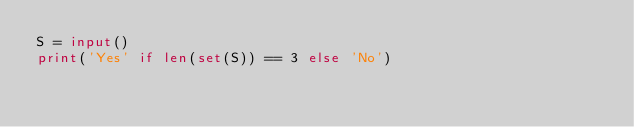Convert code to text. <code><loc_0><loc_0><loc_500><loc_500><_Python_>S = input()
print('Yes' if len(set(S)) == 3 else 'No')</code> 